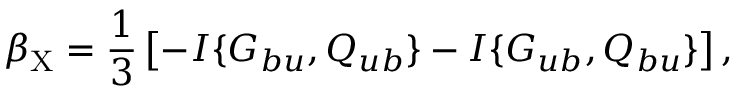Convert formula to latex. <formula><loc_0><loc_0><loc_500><loc_500>\beta _ { X } = \frac { 1 } { 3 } \left [ { - I \{ { G _ { b u } , Q _ { u b } } \} - I \{ { G _ { u b } , Q _ { b u } } \} } \right ] ,</formula> 